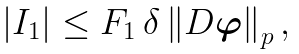Convert formula to latex. <formula><loc_0><loc_0><loc_500><loc_500>\left | I _ { 1 } \right | \leq F _ { 1 } \, \delta \left \| D \boldsymbol \varphi \right \| _ { p } ,</formula> 